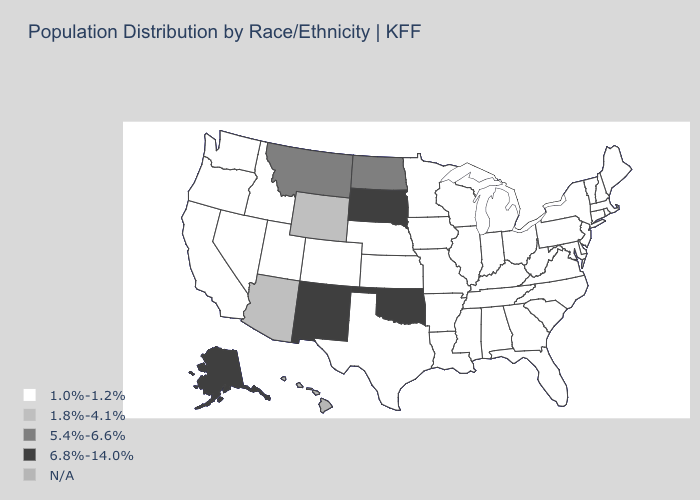Name the states that have a value in the range 5.4%-6.6%?
Give a very brief answer. Montana, North Dakota. What is the value of North Dakota?
Concise answer only. 5.4%-6.6%. What is the value of Michigan?
Answer briefly. 1.0%-1.2%. What is the value of Maine?
Keep it brief. 1.0%-1.2%. Name the states that have a value in the range 5.4%-6.6%?
Give a very brief answer. Montana, North Dakota. What is the highest value in states that border New Mexico?
Answer briefly. 6.8%-14.0%. What is the value of New Mexico?
Give a very brief answer. 6.8%-14.0%. What is the highest value in the USA?
Be succinct. 6.8%-14.0%. Name the states that have a value in the range 6.8%-14.0%?
Concise answer only. Alaska, New Mexico, Oklahoma, South Dakota. Is the legend a continuous bar?
Be succinct. No. Name the states that have a value in the range 6.8%-14.0%?
Be succinct. Alaska, New Mexico, Oklahoma, South Dakota. What is the value of Missouri?
Give a very brief answer. 1.0%-1.2%. Name the states that have a value in the range 1.8%-4.1%?
Give a very brief answer. Arizona, Wyoming. Name the states that have a value in the range 1.0%-1.2%?
Be succinct. Alabama, Arkansas, California, Colorado, Connecticut, Delaware, Florida, Georgia, Idaho, Illinois, Indiana, Iowa, Kansas, Kentucky, Louisiana, Maine, Maryland, Massachusetts, Michigan, Minnesota, Mississippi, Missouri, Nebraska, Nevada, New Hampshire, New Jersey, New York, North Carolina, Ohio, Oregon, Pennsylvania, Rhode Island, South Carolina, Tennessee, Texas, Utah, Vermont, Virginia, Washington, West Virginia, Wisconsin. 